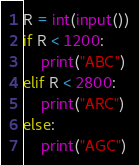Convert code to text. <code><loc_0><loc_0><loc_500><loc_500><_Python_>R = int(input())
if R < 1200:
    print("ABC")
elif R < 2800:
    print("ARC")
else:
    print("AGC")</code> 